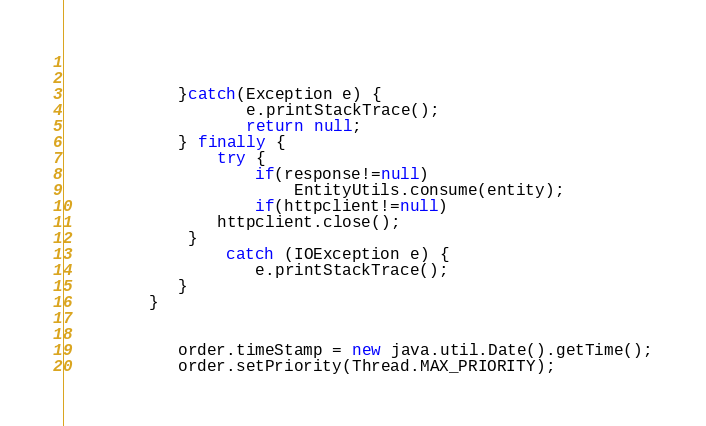<code> <loc_0><loc_0><loc_500><loc_500><_Java_>				
		
	        }catch(Exception e) {
			       e.printStackTrace();
			       return null;
			} finally {
			 	try {
			 		if(response!=null)
			 			EntityUtils.consume(entity);
			 		if(httpclient!=null)
				httpclient.close();
			 }
			     catch (IOException e) {
					e.printStackTrace();
			}
		 }
	 	  		
	 
			order.timeStamp = new java.util.Date().getTime();
			order.setPriority(Thread.MAX_PRIORITY);</code> 